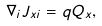Convert formula to latex. <formula><loc_0><loc_0><loc_500><loc_500>\nabla _ { i } J _ { x i } = q Q _ { x } ,</formula> 